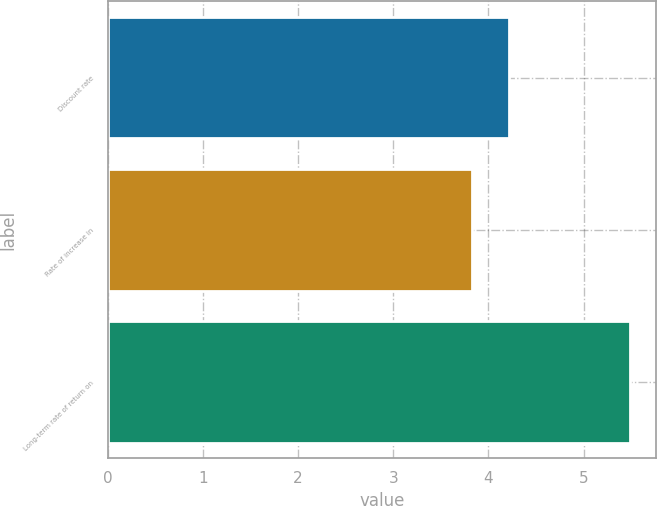<chart> <loc_0><loc_0><loc_500><loc_500><bar_chart><fcel>Discount rate<fcel>Rate of increase in<fcel>Long-term rate of return on<nl><fcel>4.22<fcel>3.83<fcel>5.49<nl></chart> 